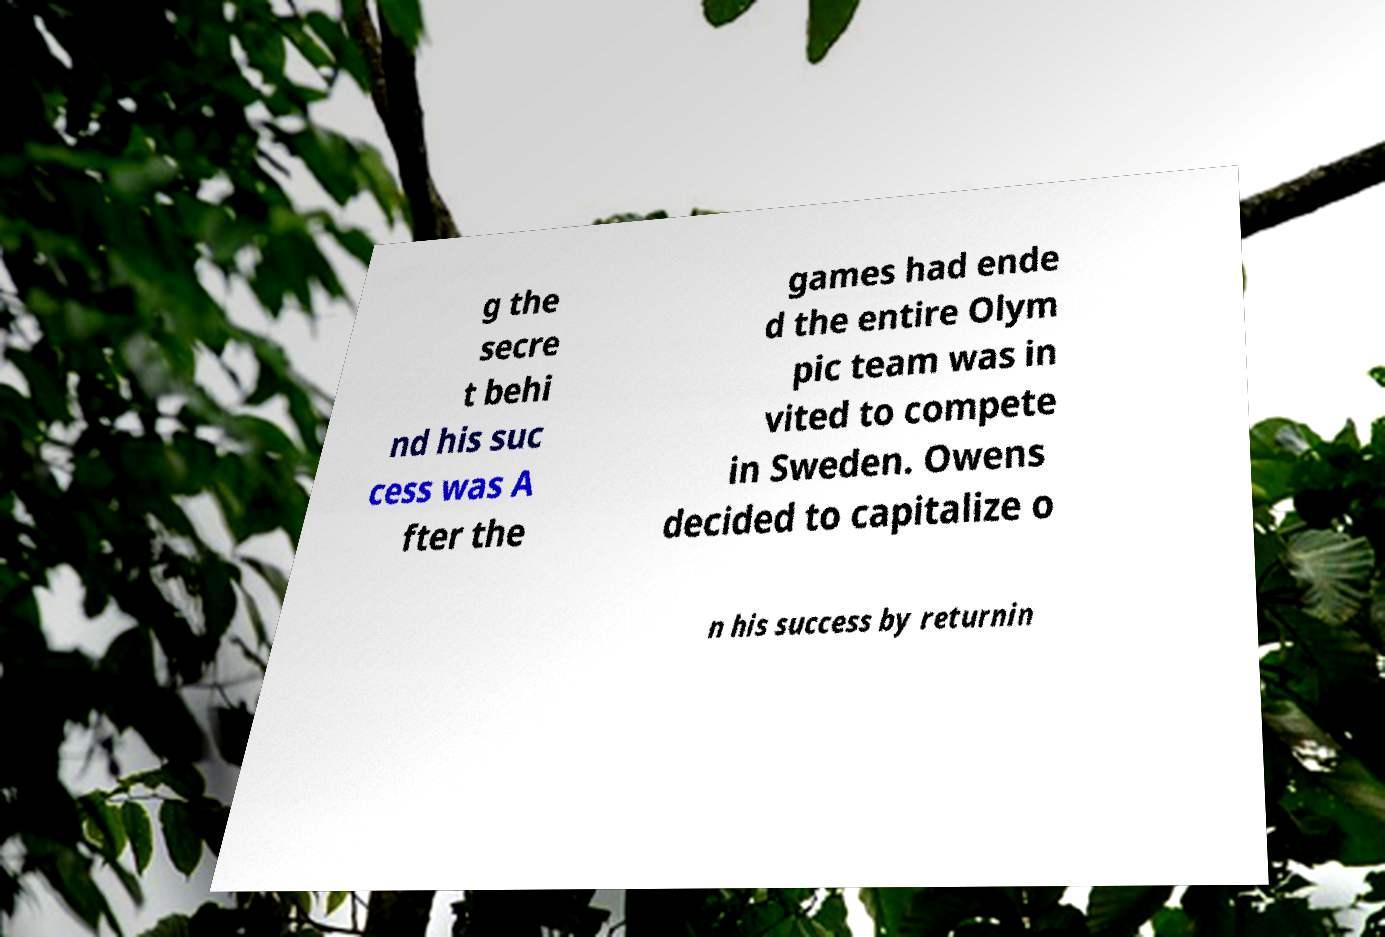Could you assist in decoding the text presented in this image and type it out clearly? g the secre t behi nd his suc cess was A fter the games had ende d the entire Olym pic team was in vited to compete in Sweden. Owens decided to capitalize o n his success by returnin 